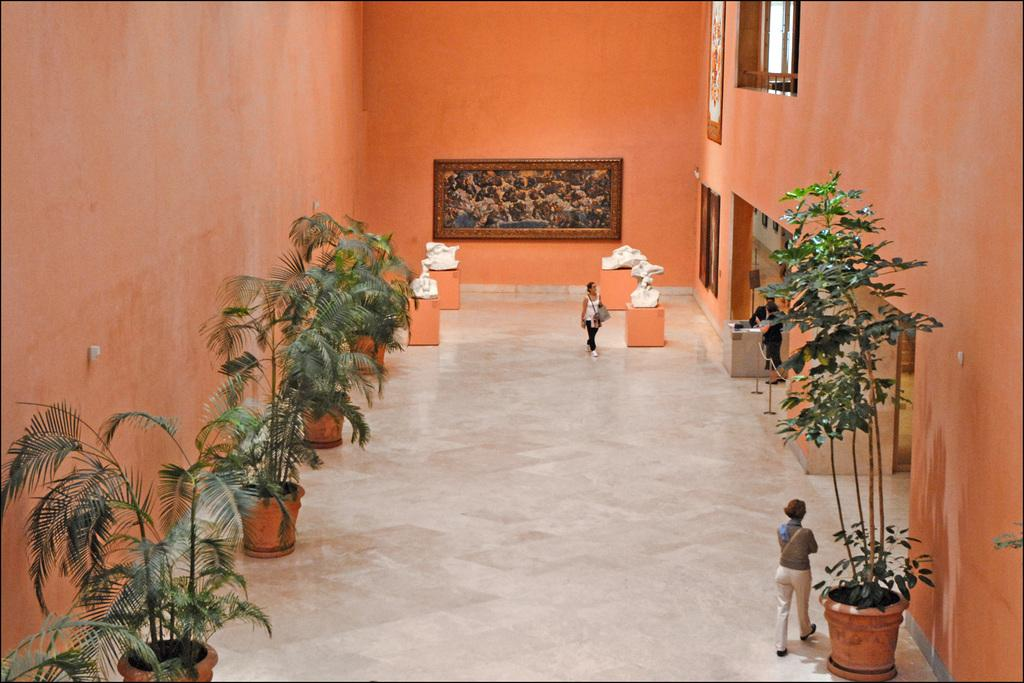Who or what can be seen in the image? There are people in the image. What type of plants are visible in the image? There are house plants in the image. What type of artwork is present in the image? There are sculptures in the image. What is hanging on the wall in the image? There is a photo frame on the wall in the image. What architectural feature is visible in the image? There is a window in the image. What type of book is being read by the people in the image? There is no book present in the image; the people are not reading. What is the weather like outside the window in the image? The provided facts do not mention the weather, so we cannot determine the weather from the image. 